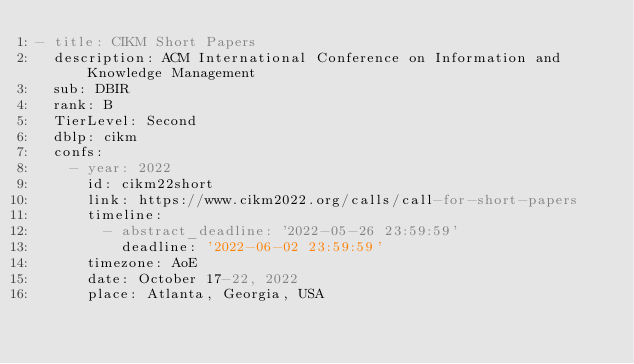Convert code to text. <code><loc_0><loc_0><loc_500><loc_500><_YAML_>- title: CIKM Short Papers
  description: ACM International Conference on Information and Knowledge Management
  sub: DBIR
  rank: B
  TierLevel: Second
  dblp: cikm
  confs:
    - year: 2022
      id: cikm22short
      link: https://www.cikm2022.org/calls/call-for-short-papers
      timeline:
        - abstract_deadline: '2022-05-26 23:59:59'
          deadline: '2022-06-02 23:59:59'
      timezone: AoE
      date: October 17-22, 2022
      place: Atlanta, Georgia, USA</code> 